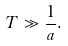<formula> <loc_0><loc_0><loc_500><loc_500>T \gg \frac { 1 } { a } .</formula> 